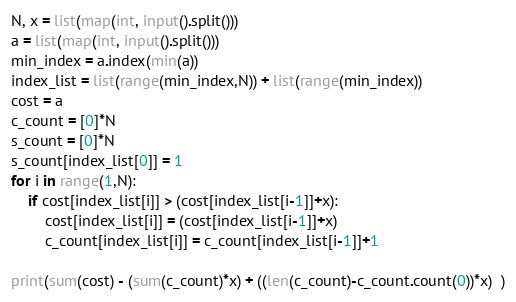<code> <loc_0><loc_0><loc_500><loc_500><_Python_>N, x = list(map(int, input().split()))
a = list(map(int, input().split()))
min_index = a.index(min(a))
index_list = list(range(min_index,N)) + list(range(min_index))
cost = a
c_count = [0]*N
s_count = [0]*N
s_count[index_list[0]] = 1
for i in range(1,N):
    if cost[index_list[i]] > (cost[index_list[i-1]]+x):
        cost[index_list[i]] = (cost[index_list[i-1]]+x)
        c_count[index_list[i]] = c_count[index_list[i-1]]+1

print(sum(cost) - (sum(c_count)*x) + ((len(c_count)-c_count.count(0))*x)  )
</code> 